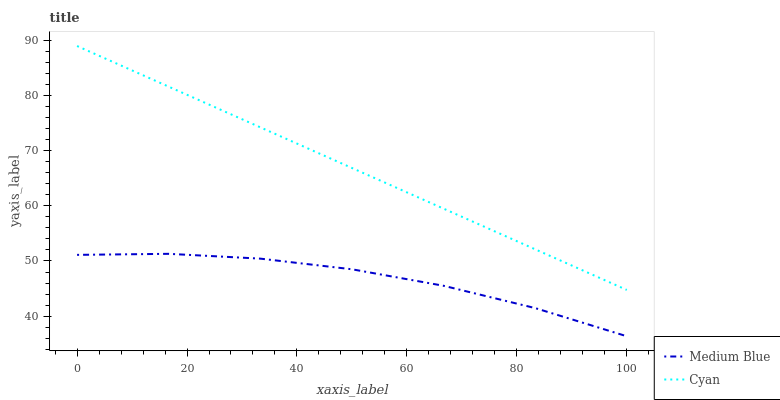Does Medium Blue have the minimum area under the curve?
Answer yes or no. Yes. Does Cyan have the maximum area under the curve?
Answer yes or no. Yes. Does Medium Blue have the maximum area under the curve?
Answer yes or no. No. Is Cyan the smoothest?
Answer yes or no. Yes. Is Medium Blue the roughest?
Answer yes or no. Yes. Is Medium Blue the smoothest?
Answer yes or no. No. Does Medium Blue have the highest value?
Answer yes or no. No. Is Medium Blue less than Cyan?
Answer yes or no. Yes. Is Cyan greater than Medium Blue?
Answer yes or no. Yes. Does Medium Blue intersect Cyan?
Answer yes or no. No. 